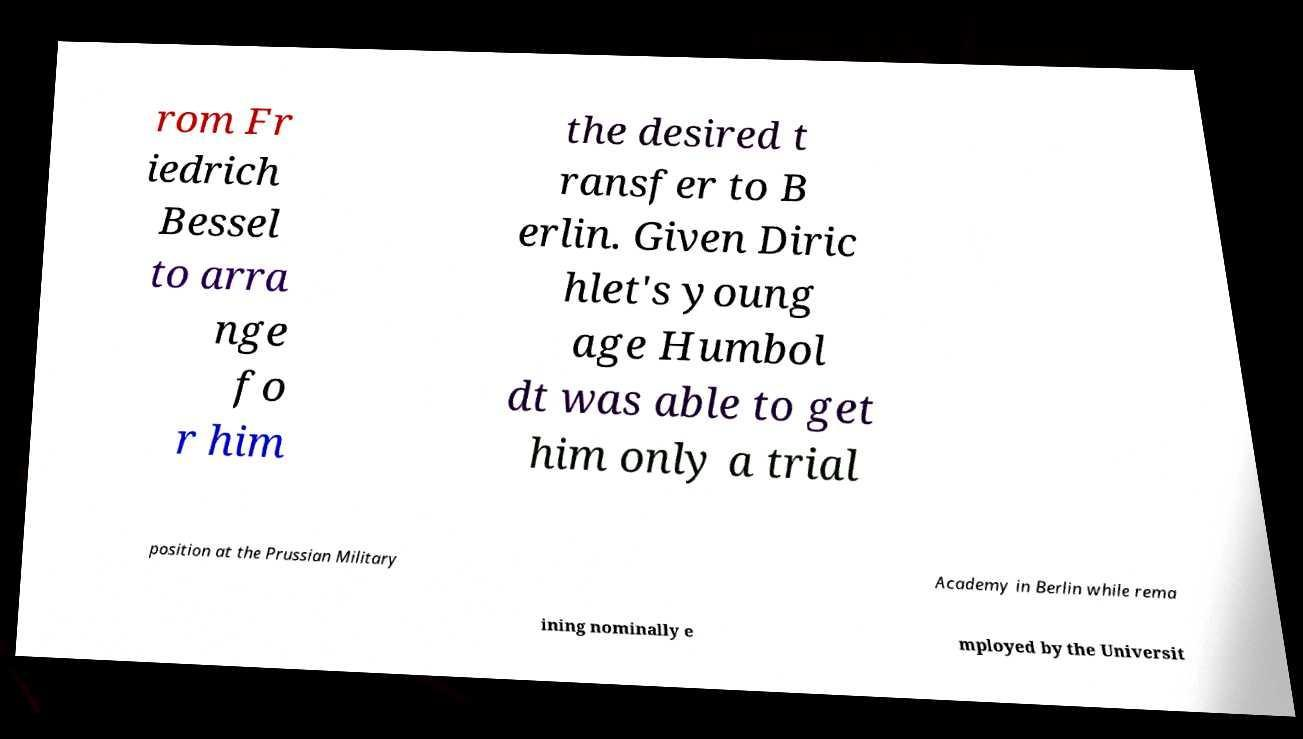Could you extract and type out the text from this image? rom Fr iedrich Bessel to arra nge fo r him the desired t ransfer to B erlin. Given Diric hlet's young age Humbol dt was able to get him only a trial position at the Prussian Military Academy in Berlin while rema ining nominally e mployed by the Universit 